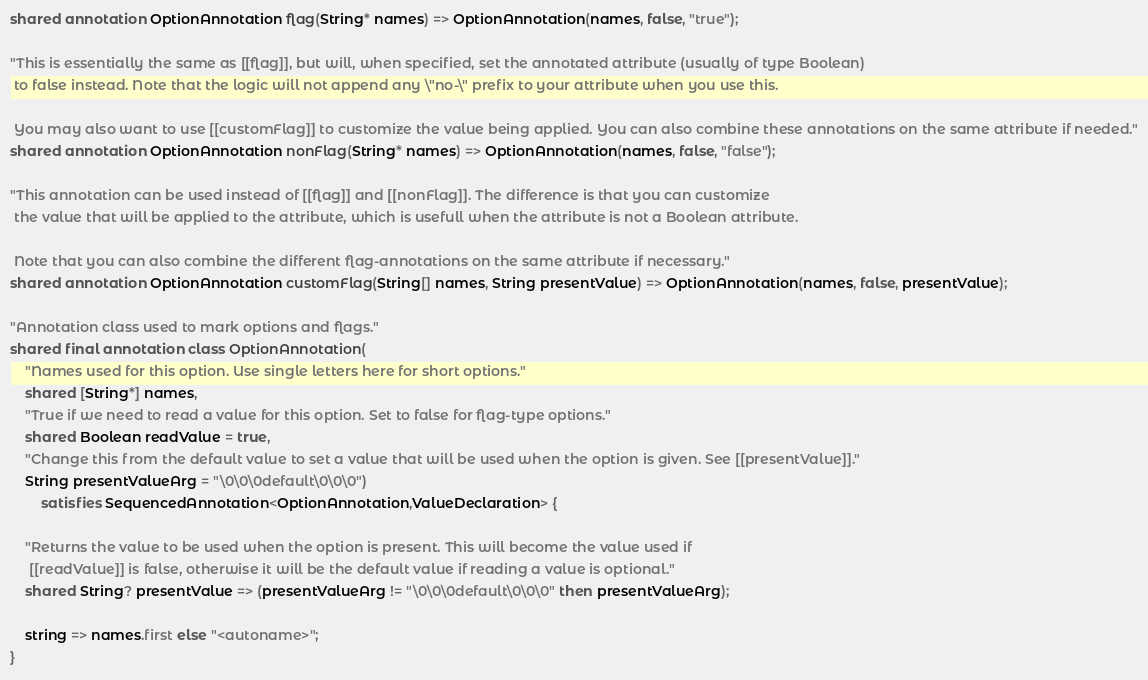Convert code to text. <code><loc_0><loc_0><loc_500><loc_500><_Ceylon_>shared annotation OptionAnnotation flag(String* names) => OptionAnnotation(names, false, "true");

"This is essentially the same as [[flag]], but will, when specified, set the annotated attribute (usually of type Boolean)
 to false instead. Note that the logic will not append any \"no-\" prefix to your attribute when you use this.

 You may also want to use [[customFlag]] to customize the value being applied. You can also combine these annotations on the same attribute if needed."
shared annotation OptionAnnotation nonFlag(String* names) => OptionAnnotation(names, false, "false");

"This annotation can be used instead of [[flag]] and [[nonFlag]]. The difference is that you can customize
 the value that will be applied to the attribute, which is usefull when the attribute is not a Boolean attribute.

 Note that you can also combine the different flag-annotations on the same attribute if necessary."
shared annotation OptionAnnotation customFlag(String[] names, String presentValue) => OptionAnnotation(names, false, presentValue);

"Annotation class used to mark options and flags."
shared final annotation class OptionAnnotation(
	"Names used for this option. Use single letters here for short options."
	shared [String*] names,
	"True if we need to read a value for this option. Set to false for flag-type options."
	shared Boolean readValue = true,
	"Change this from the default value to set a value that will be used when the option is given. See [[presentValue]]."
	String presentValueArg = "\0\0\0default\0\0\0")
		satisfies SequencedAnnotation<OptionAnnotation,ValueDeclaration> {

	"Returns the value to be used when the option is present. This will become the value used if
	 [[readValue]] is false, otherwise it will be the default value if reading a value is optional."
	shared String? presentValue => (presentValueArg != "\0\0\0default\0\0\0" then presentValueArg);

	string => names.first else "<autoname>";
}
</code> 